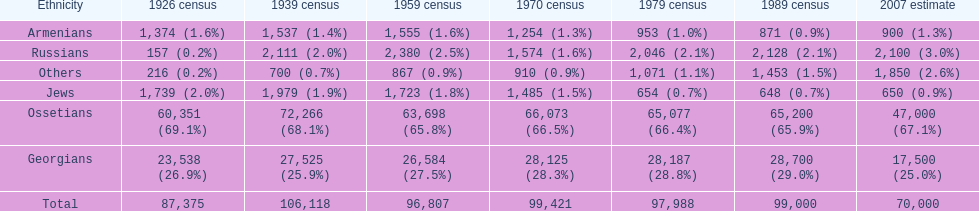Who is previous of the russians based on the list? Georgians. 